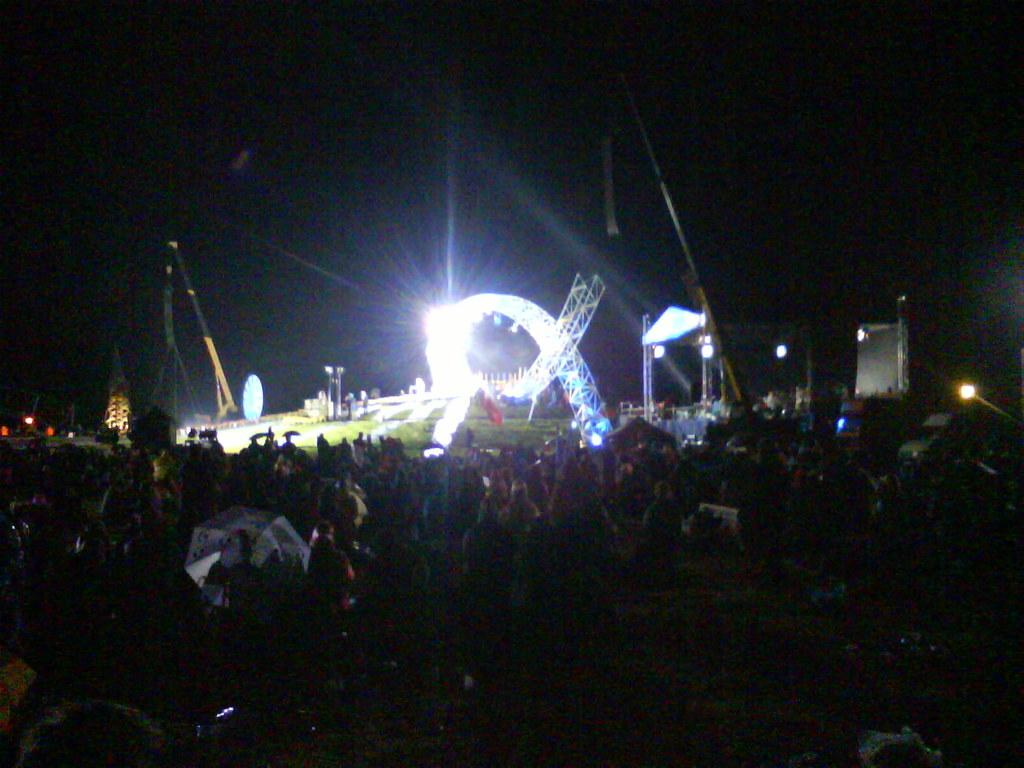Who or what can be seen in the image? There are people in the image. What object is present to provide shade or protection from the elements? There is an umbrella in the image. What can be seen providing illumination in the image? There are lights in the image. What structures are present in the image that might be used for support or stability? There are poles in the image. What else is visible in the image besides the people, umbrella, lights, and poles? There are objects in the image. How much does the snow weigh in the image? There is no snow present in the image, so it is not possible to determine its weight. 